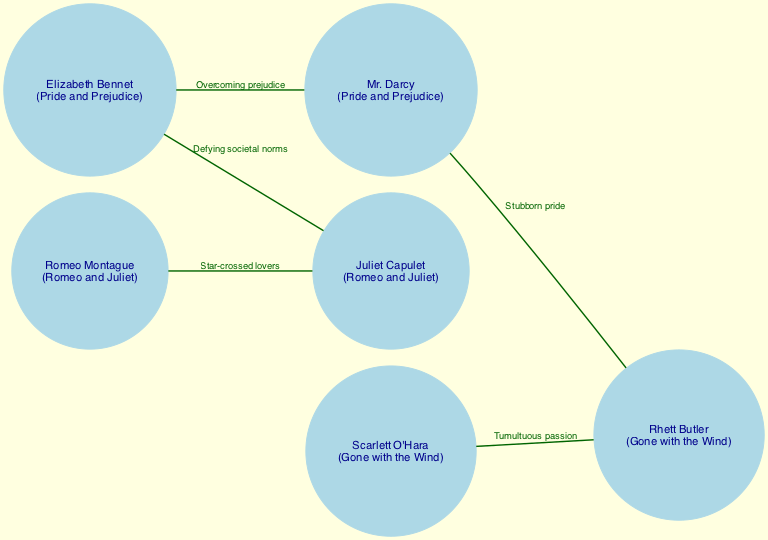What are the names of the couples connected by a "Star-crossed lovers" relationship? The diagram shows two connections representing "Star-crossed lovers": Romeo Montague and Juliet Capulet. This can be confirmed by locating the edge labeled "Star-crossed lovers" and identifying the nodes it connects.
Answer: Romeo Montague and Juliet Capulet How many nodes are in the diagram? The diagram consists of six distinct nodes representing famous literary characters. This is determined by counting each unique node depicted in the diagram.
Answer: 6 What is the relationship between Elizabeth Bennet and Mr. Darcy? The connection between Elizabeth Bennet and Mr. Darcy is labeled as "Overcoming prejudice." To find this, one can look for the edge that connects these two specific nodes and read the label attached to it.
Answer: Overcoming prejudice Which character from "Gone with the Wind" is connected to Elizabeth Bennet? Rhett Butler is connected to Elizabeth Bennet through an edge that highlights the relationship of "Stubborn pride." This can be validated by tracing the connections in the diagram from Elizabeth Bennet to Rhett Butler.
Answer: Rhett Butler What is the total number of edges in the diagram? The diagram features five edges that link pairs of nodes. This total can be derived by counting each line that connects two characters in the social network graph.
Answer: 5 Which character has a relationship defined as "Tumultuous passion"? The relationship defined as "Tumultuous passion" connects Scarlett O'Hara and Rhett Butler. This is determined by identifying the edge labeled "Tumultuous passion" and noting the characters connected by it.
Answer: Scarlett O'Hara and Rhett Butler Are there any connections that reflect a theme of defiance against social norms? Yes, the relationship between Elizabeth Bennet and Juliet Capulet exemplifies the theme of defying societal norms. This can be concluded by locating the edges that describe such themes and identifying the characters involved.
Answer: Yes What two couples have a shared characteristic regarding societal norms? Elizabeth Bennet and Mr. Darcy, and Elizabeth Bennet and Juliet Capulet both demonstrate the characteristic of defying societal norms. By analyzing the connections and relationships outlined in the diagram, they can be pinpointed.
Answer: Elizabeth Bennet and Mr. Darcy; Elizabeth Bennet and Juliet Capulet 